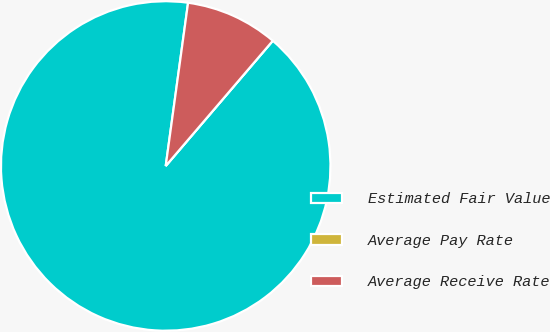Convert chart. <chart><loc_0><loc_0><loc_500><loc_500><pie_chart><fcel>Estimated Fair Value<fcel>Average Pay Rate<fcel>Average Receive Rate<nl><fcel>90.9%<fcel>0.0%<fcel>9.09%<nl></chart> 